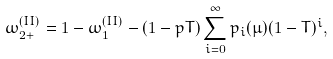Convert formula to latex. <formula><loc_0><loc_0><loc_500><loc_500>\omega _ { 2 + } ^ { ( I I ) } = 1 - \omega ^ { ( I I ) } _ { 1 } - ( 1 - p T ) \sum _ { i = 0 } ^ { \infty } p _ { i } ( \mu ) ( 1 - T ) ^ { i } ,</formula> 